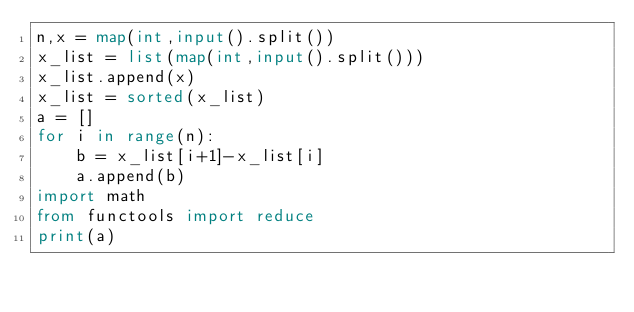<code> <loc_0><loc_0><loc_500><loc_500><_Python_>n,x = map(int,input().split())
x_list = list(map(int,input().split()))
x_list.append(x)
x_list = sorted(x_list)
a = []
for i in range(n):
    b = x_list[i+1]-x_list[i]
    a.append(b)
import math
from functools import reduce
print(a)</code> 